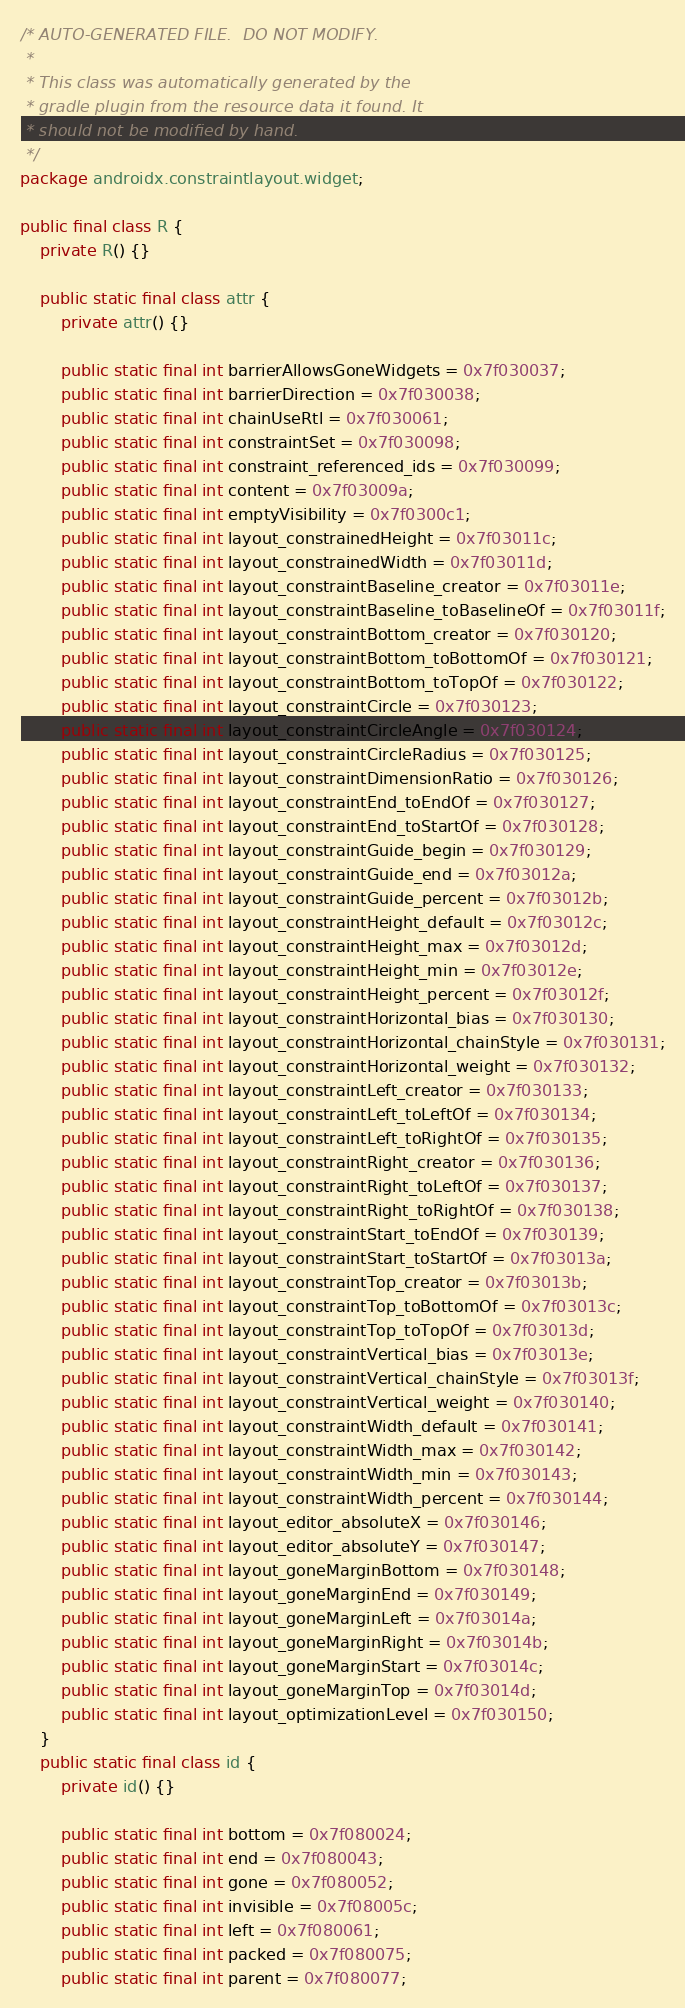<code> <loc_0><loc_0><loc_500><loc_500><_Java_>/* AUTO-GENERATED FILE.  DO NOT MODIFY.
 *
 * This class was automatically generated by the
 * gradle plugin from the resource data it found. It
 * should not be modified by hand.
 */
package androidx.constraintlayout.widget;

public final class R {
    private R() {}

    public static final class attr {
        private attr() {}

        public static final int barrierAllowsGoneWidgets = 0x7f030037;
        public static final int barrierDirection = 0x7f030038;
        public static final int chainUseRtl = 0x7f030061;
        public static final int constraintSet = 0x7f030098;
        public static final int constraint_referenced_ids = 0x7f030099;
        public static final int content = 0x7f03009a;
        public static final int emptyVisibility = 0x7f0300c1;
        public static final int layout_constrainedHeight = 0x7f03011c;
        public static final int layout_constrainedWidth = 0x7f03011d;
        public static final int layout_constraintBaseline_creator = 0x7f03011e;
        public static final int layout_constraintBaseline_toBaselineOf = 0x7f03011f;
        public static final int layout_constraintBottom_creator = 0x7f030120;
        public static final int layout_constraintBottom_toBottomOf = 0x7f030121;
        public static final int layout_constraintBottom_toTopOf = 0x7f030122;
        public static final int layout_constraintCircle = 0x7f030123;
        public static final int layout_constraintCircleAngle = 0x7f030124;
        public static final int layout_constraintCircleRadius = 0x7f030125;
        public static final int layout_constraintDimensionRatio = 0x7f030126;
        public static final int layout_constraintEnd_toEndOf = 0x7f030127;
        public static final int layout_constraintEnd_toStartOf = 0x7f030128;
        public static final int layout_constraintGuide_begin = 0x7f030129;
        public static final int layout_constraintGuide_end = 0x7f03012a;
        public static final int layout_constraintGuide_percent = 0x7f03012b;
        public static final int layout_constraintHeight_default = 0x7f03012c;
        public static final int layout_constraintHeight_max = 0x7f03012d;
        public static final int layout_constraintHeight_min = 0x7f03012e;
        public static final int layout_constraintHeight_percent = 0x7f03012f;
        public static final int layout_constraintHorizontal_bias = 0x7f030130;
        public static final int layout_constraintHorizontal_chainStyle = 0x7f030131;
        public static final int layout_constraintHorizontal_weight = 0x7f030132;
        public static final int layout_constraintLeft_creator = 0x7f030133;
        public static final int layout_constraintLeft_toLeftOf = 0x7f030134;
        public static final int layout_constraintLeft_toRightOf = 0x7f030135;
        public static final int layout_constraintRight_creator = 0x7f030136;
        public static final int layout_constraintRight_toLeftOf = 0x7f030137;
        public static final int layout_constraintRight_toRightOf = 0x7f030138;
        public static final int layout_constraintStart_toEndOf = 0x7f030139;
        public static final int layout_constraintStart_toStartOf = 0x7f03013a;
        public static final int layout_constraintTop_creator = 0x7f03013b;
        public static final int layout_constraintTop_toBottomOf = 0x7f03013c;
        public static final int layout_constraintTop_toTopOf = 0x7f03013d;
        public static final int layout_constraintVertical_bias = 0x7f03013e;
        public static final int layout_constraintVertical_chainStyle = 0x7f03013f;
        public static final int layout_constraintVertical_weight = 0x7f030140;
        public static final int layout_constraintWidth_default = 0x7f030141;
        public static final int layout_constraintWidth_max = 0x7f030142;
        public static final int layout_constraintWidth_min = 0x7f030143;
        public static final int layout_constraintWidth_percent = 0x7f030144;
        public static final int layout_editor_absoluteX = 0x7f030146;
        public static final int layout_editor_absoluteY = 0x7f030147;
        public static final int layout_goneMarginBottom = 0x7f030148;
        public static final int layout_goneMarginEnd = 0x7f030149;
        public static final int layout_goneMarginLeft = 0x7f03014a;
        public static final int layout_goneMarginRight = 0x7f03014b;
        public static final int layout_goneMarginStart = 0x7f03014c;
        public static final int layout_goneMarginTop = 0x7f03014d;
        public static final int layout_optimizationLevel = 0x7f030150;
    }
    public static final class id {
        private id() {}

        public static final int bottom = 0x7f080024;
        public static final int end = 0x7f080043;
        public static final int gone = 0x7f080052;
        public static final int invisible = 0x7f08005c;
        public static final int left = 0x7f080061;
        public static final int packed = 0x7f080075;
        public static final int parent = 0x7f080077;</code> 